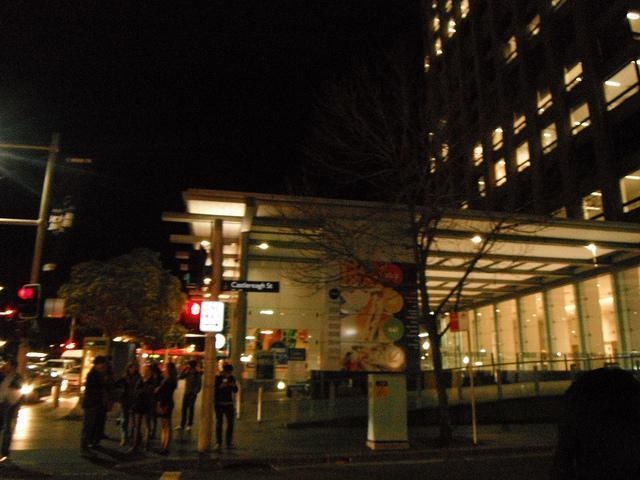How many people are there?
Give a very brief answer. 7. 